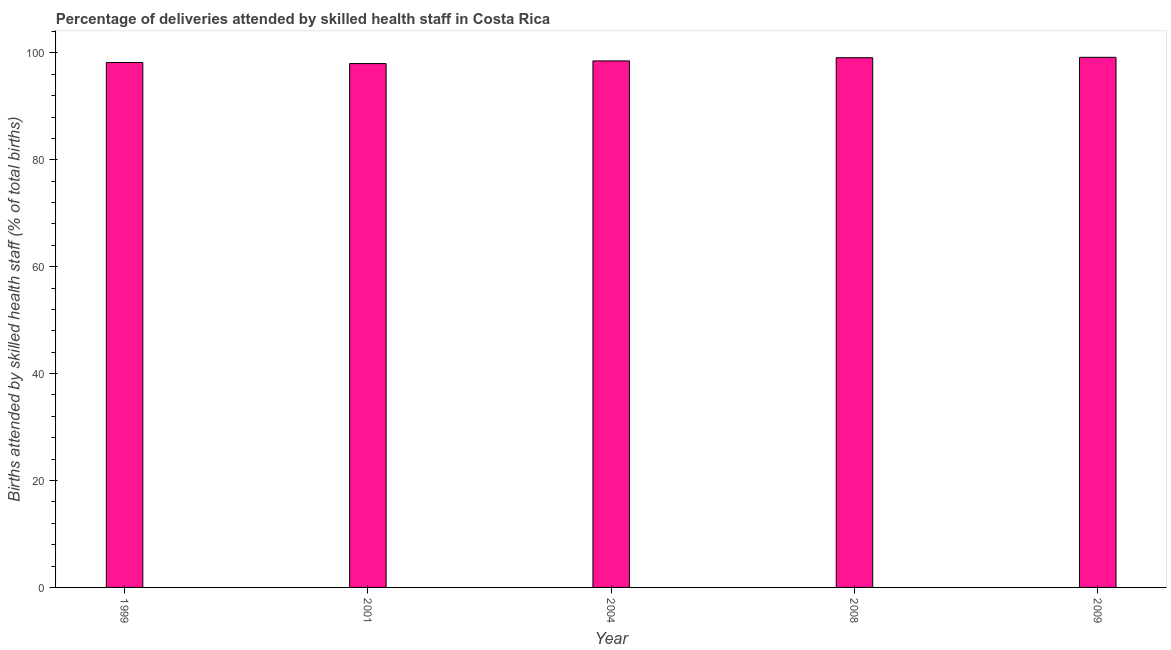Does the graph contain grids?
Ensure brevity in your answer.  No. What is the title of the graph?
Your response must be concise. Percentage of deliveries attended by skilled health staff in Costa Rica. What is the label or title of the Y-axis?
Ensure brevity in your answer.  Births attended by skilled health staff (% of total births). What is the number of births attended by skilled health staff in 2008?
Offer a terse response. 99.1. Across all years, what is the maximum number of births attended by skilled health staff?
Your response must be concise. 99.17. In which year was the number of births attended by skilled health staff maximum?
Keep it short and to the point. 2009. What is the sum of the number of births attended by skilled health staff?
Provide a succinct answer. 492.97. What is the average number of births attended by skilled health staff per year?
Provide a short and direct response. 98.59. What is the median number of births attended by skilled health staff?
Keep it short and to the point. 98.5. In how many years, is the number of births attended by skilled health staff greater than 72 %?
Ensure brevity in your answer.  5. What is the ratio of the number of births attended by skilled health staff in 2004 to that in 2009?
Provide a short and direct response. 0.99. Is the number of births attended by skilled health staff in 2004 less than that in 2008?
Ensure brevity in your answer.  Yes. Is the difference between the number of births attended by skilled health staff in 2004 and 2009 greater than the difference between any two years?
Keep it short and to the point. No. What is the difference between the highest and the second highest number of births attended by skilled health staff?
Provide a succinct answer. 0.07. What is the difference between the highest and the lowest number of births attended by skilled health staff?
Your answer should be compact. 1.17. In how many years, is the number of births attended by skilled health staff greater than the average number of births attended by skilled health staff taken over all years?
Your answer should be very brief. 2. How many bars are there?
Offer a very short reply. 5. What is the difference between two consecutive major ticks on the Y-axis?
Keep it short and to the point. 20. Are the values on the major ticks of Y-axis written in scientific E-notation?
Your answer should be very brief. No. What is the Births attended by skilled health staff (% of total births) of 1999?
Keep it short and to the point. 98.2. What is the Births attended by skilled health staff (% of total births) in 2001?
Provide a succinct answer. 98. What is the Births attended by skilled health staff (% of total births) in 2004?
Provide a short and direct response. 98.5. What is the Births attended by skilled health staff (% of total births) of 2008?
Ensure brevity in your answer.  99.1. What is the Births attended by skilled health staff (% of total births) in 2009?
Make the answer very short. 99.17. What is the difference between the Births attended by skilled health staff (% of total births) in 1999 and 2009?
Offer a very short reply. -0.97. What is the difference between the Births attended by skilled health staff (% of total births) in 2001 and 2009?
Ensure brevity in your answer.  -1.17. What is the difference between the Births attended by skilled health staff (% of total births) in 2004 and 2008?
Provide a succinct answer. -0.6. What is the difference between the Births attended by skilled health staff (% of total births) in 2004 and 2009?
Keep it short and to the point. -0.67. What is the difference between the Births attended by skilled health staff (% of total births) in 2008 and 2009?
Keep it short and to the point. -0.07. What is the ratio of the Births attended by skilled health staff (% of total births) in 1999 to that in 2001?
Offer a very short reply. 1. What is the ratio of the Births attended by skilled health staff (% of total births) in 1999 to that in 2004?
Your answer should be compact. 1. What is the ratio of the Births attended by skilled health staff (% of total births) in 1999 to that in 2009?
Make the answer very short. 0.99. What is the ratio of the Births attended by skilled health staff (% of total births) in 2001 to that in 2004?
Ensure brevity in your answer.  0.99. What is the ratio of the Births attended by skilled health staff (% of total births) in 2004 to that in 2009?
Offer a very short reply. 0.99. 